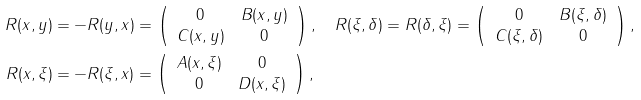Convert formula to latex. <formula><loc_0><loc_0><loc_500><loc_500>R ( x , y ) & = - R ( y , x ) = \left ( \begin{array} { c c } 0 & B ( x , y ) \\ C ( x , y ) & 0 \end{array} \right ) , \quad R ( \xi , \delta ) = R ( \delta , \xi ) = \left ( \begin{array} { c c } 0 & B ( \xi , \delta ) \\ C ( \xi , \delta ) & 0 \end{array} \right ) , \\ R ( x , \xi ) & = - R ( \xi , x ) = \left ( \begin{array} { c c } A ( x , \xi ) & 0 \\ 0 & D ( x , \xi ) \end{array} \right ) ,</formula> 